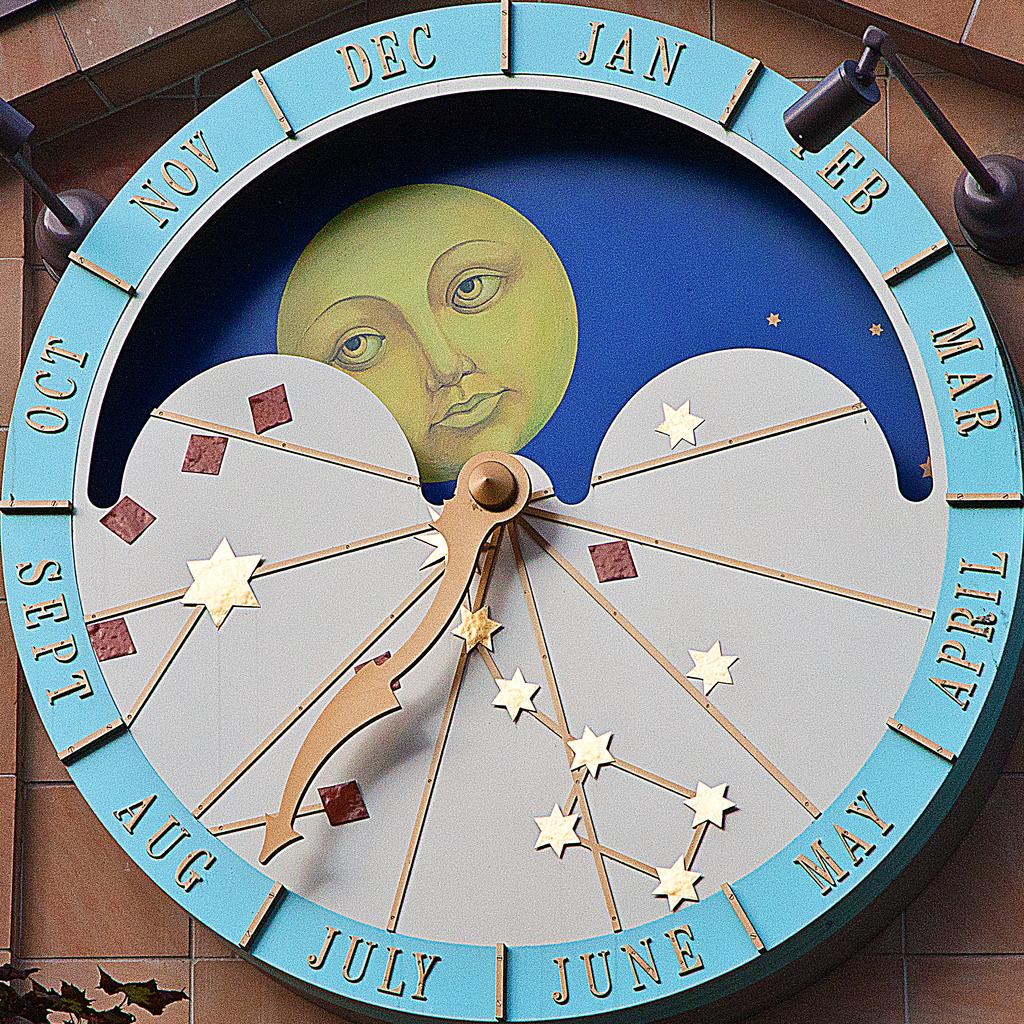<image>
Share a concise interpretation of the image provided. A large clock that depicts the months of the year has an arm pointing at August. 